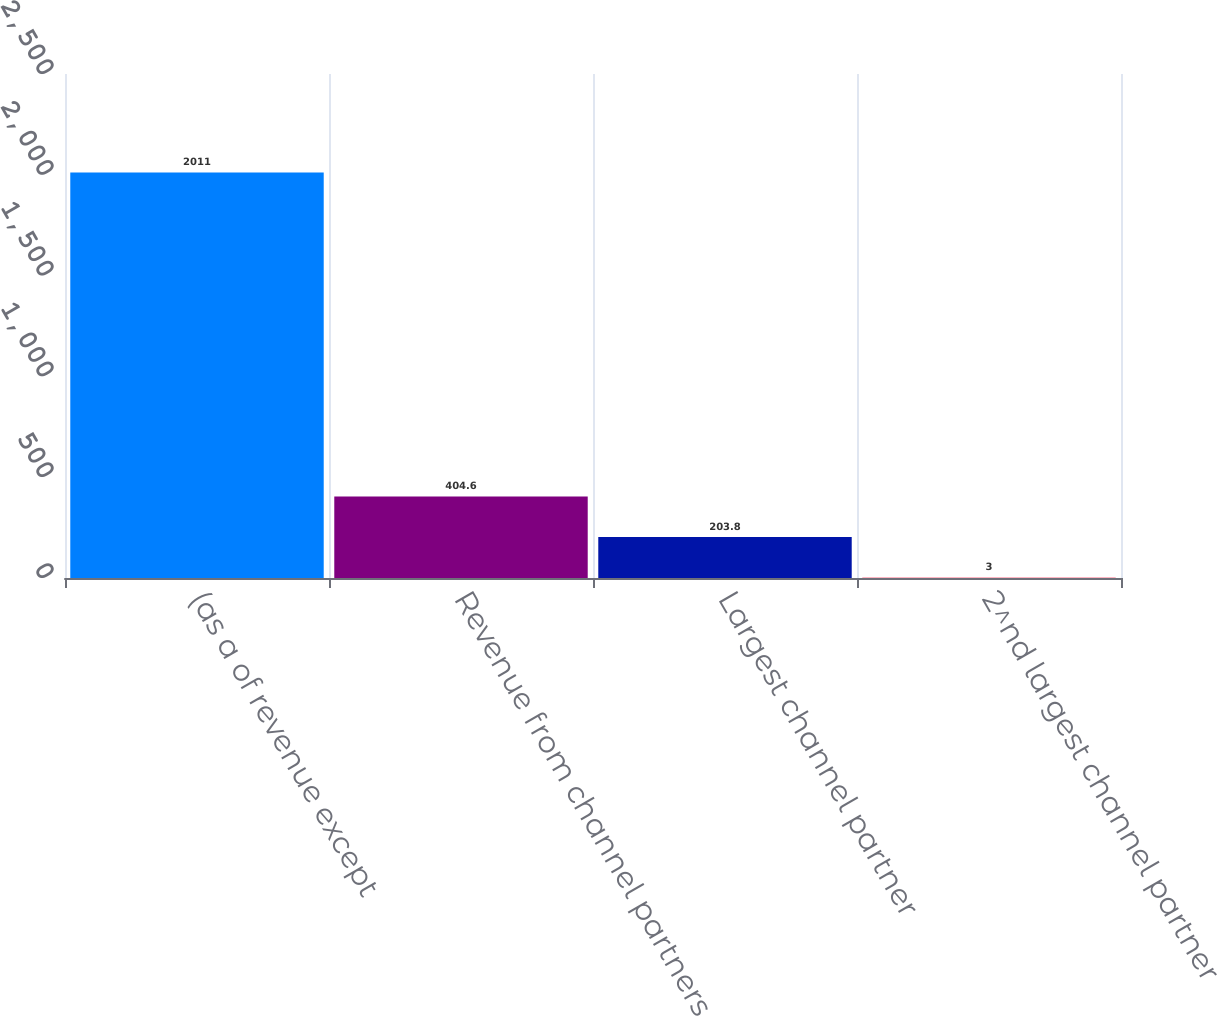Convert chart to OTSL. <chart><loc_0><loc_0><loc_500><loc_500><bar_chart><fcel>(as a of revenue except<fcel>Revenue from channel partners<fcel>Largest channel partner<fcel>2^nd largest channel partner<nl><fcel>2011<fcel>404.6<fcel>203.8<fcel>3<nl></chart> 